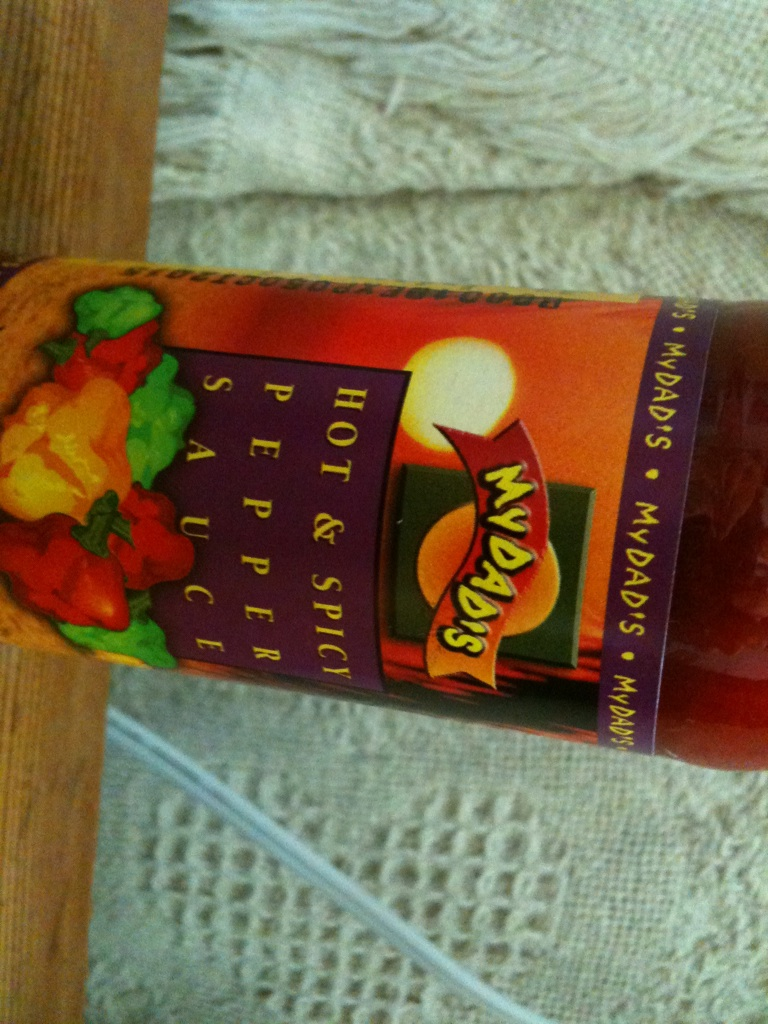Could you describe a dish that uses this pepper sauce in detail? Certainly! One popular dish that features pepper sauce is Spicy Grilled Chicken Wings. Marinate chicken wings in a mixture of the pepper sauce, olive oil, lemon juice, garlic, and a pinch of salt. Allow the wings to soak up the flavors for at least two hours. Grill the marinated wings over medium-high heat until they are cooked through and have a nice char. Serve them with a side of ranch or blue cheese dressing and celery sticks. The pepper sauce adds a kick of heat and depth of flavor that complements the smoky char from the grill. 